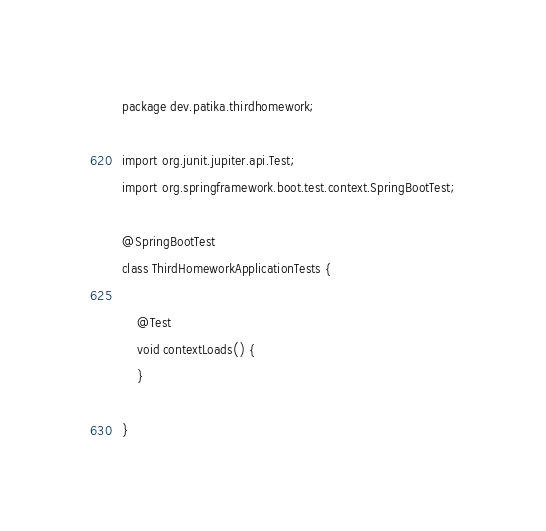<code> <loc_0><loc_0><loc_500><loc_500><_Java_>package dev.patika.thirdhomework;

import org.junit.jupiter.api.Test;
import org.springframework.boot.test.context.SpringBootTest;

@SpringBootTest
class ThirdHomeworkApplicationTests {

    @Test
    void contextLoads() {
    }

}
</code> 